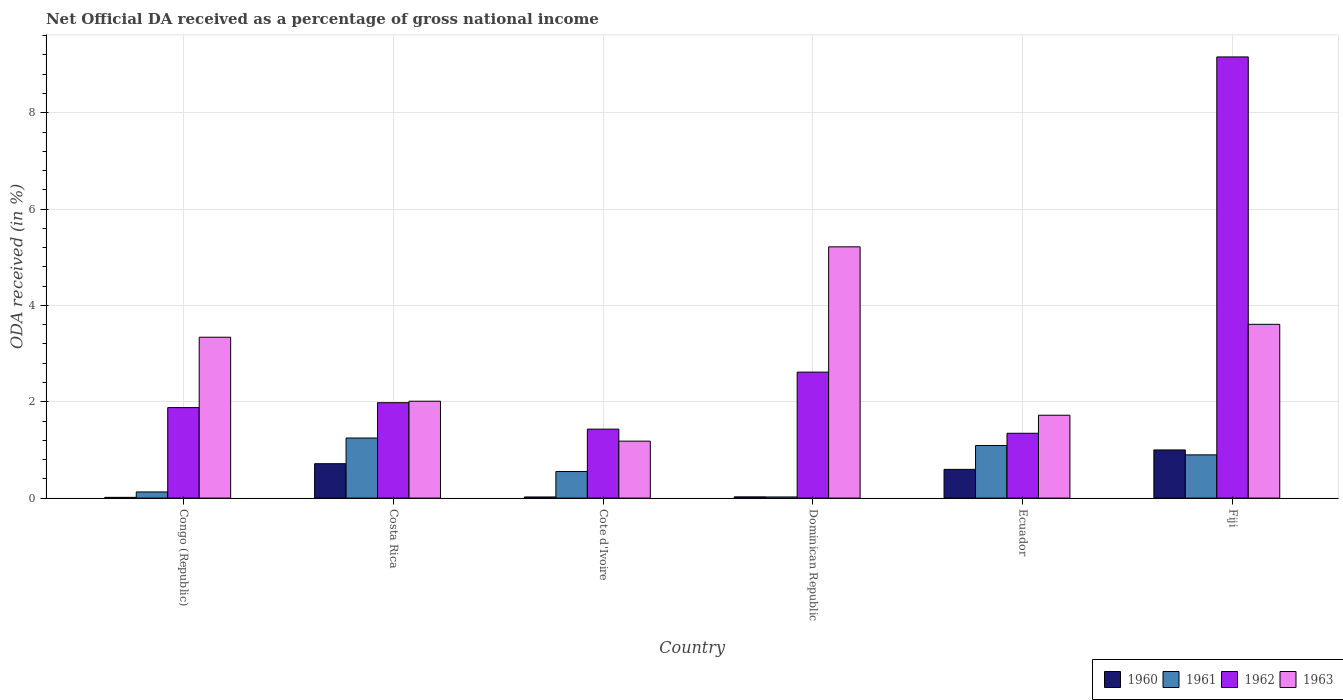How many different coloured bars are there?
Your answer should be compact. 4. Are the number of bars per tick equal to the number of legend labels?
Your answer should be compact. Yes. Are the number of bars on each tick of the X-axis equal?
Keep it short and to the point. Yes. What is the label of the 1st group of bars from the left?
Your answer should be very brief. Congo (Republic). What is the net official DA received in 1960 in Ecuador?
Provide a short and direct response. 0.6. Across all countries, what is the maximum net official DA received in 1962?
Ensure brevity in your answer.  9.16. Across all countries, what is the minimum net official DA received in 1962?
Make the answer very short. 1.35. In which country was the net official DA received in 1960 minimum?
Your answer should be very brief. Congo (Republic). What is the total net official DA received in 1960 in the graph?
Make the answer very short. 2.37. What is the difference between the net official DA received in 1961 in Congo (Republic) and that in Fiji?
Offer a very short reply. -0.77. What is the difference between the net official DA received in 1961 in Cote d'Ivoire and the net official DA received in 1960 in Congo (Republic)?
Your answer should be very brief. 0.54. What is the average net official DA received in 1960 per country?
Make the answer very short. 0.4. What is the difference between the net official DA received of/in 1962 and net official DA received of/in 1963 in Ecuador?
Ensure brevity in your answer.  -0.37. What is the ratio of the net official DA received in 1962 in Dominican Republic to that in Ecuador?
Provide a succinct answer. 1.94. Is the net official DA received in 1962 in Cote d'Ivoire less than that in Dominican Republic?
Offer a very short reply. Yes. Is the difference between the net official DA received in 1962 in Cote d'Ivoire and Dominican Republic greater than the difference between the net official DA received in 1963 in Cote d'Ivoire and Dominican Republic?
Provide a succinct answer. Yes. What is the difference between the highest and the second highest net official DA received in 1960?
Ensure brevity in your answer.  0.29. What is the difference between the highest and the lowest net official DA received in 1961?
Your answer should be very brief. 1.22. Is it the case that in every country, the sum of the net official DA received in 1963 and net official DA received in 1962 is greater than the sum of net official DA received in 1960 and net official DA received in 1961?
Keep it short and to the point. No. Is it the case that in every country, the sum of the net official DA received in 1962 and net official DA received in 1961 is greater than the net official DA received in 1963?
Make the answer very short. No. What is the difference between two consecutive major ticks on the Y-axis?
Offer a very short reply. 2. Does the graph contain grids?
Your answer should be compact. Yes. How many legend labels are there?
Make the answer very short. 4. What is the title of the graph?
Your answer should be very brief. Net Official DA received as a percentage of gross national income. What is the label or title of the Y-axis?
Provide a succinct answer. ODA received (in %). What is the ODA received (in %) in 1960 in Congo (Republic)?
Your response must be concise. 0.02. What is the ODA received (in %) of 1961 in Congo (Republic)?
Keep it short and to the point. 0.13. What is the ODA received (in %) of 1962 in Congo (Republic)?
Make the answer very short. 1.88. What is the ODA received (in %) of 1963 in Congo (Republic)?
Provide a succinct answer. 3.34. What is the ODA received (in %) of 1960 in Costa Rica?
Make the answer very short. 0.71. What is the ODA received (in %) in 1961 in Costa Rica?
Offer a terse response. 1.25. What is the ODA received (in %) in 1962 in Costa Rica?
Give a very brief answer. 1.98. What is the ODA received (in %) of 1963 in Costa Rica?
Your response must be concise. 2.01. What is the ODA received (in %) of 1960 in Cote d'Ivoire?
Your answer should be very brief. 0.02. What is the ODA received (in %) in 1961 in Cote d'Ivoire?
Make the answer very short. 0.55. What is the ODA received (in %) of 1962 in Cote d'Ivoire?
Offer a very short reply. 1.43. What is the ODA received (in %) of 1963 in Cote d'Ivoire?
Your answer should be very brief. 1.18. What is the ODA received (in %) in 1960 in Dominican Republic?
Offer a very short reply. 0.03. What is the ODA received (in %) in 1961 in Dominican Republic?
Ensure brevity in your answer.  0.02. What is the ODA received (in %) in 1962 in Dominican Republic?
Offer a very short reply. 2.62. What is the ODA received (in %) of 1963 in Dominican Republic?
Your answer should be compact. 5.22. What is the ODA received (in %) in 1960 in Ecuador?
Give a very brief answer. 0.6. What is the ODA received (in %) of 1961 in Ecuador?
Your answer should be compact. 1.09. What is the ODA received (in %) in 1962 in Ecuador?
Your answer should be compact. 1.35. What is the ODA received (in %) in 1963 in Ecuador?
Offer a very short reply. 1.72. What is the ODA received (in %) in 1960 in Fiji?
Offer a terse response. 1. What is the ODA received (in %) in 1961 in Fiji?
Your answer should be compact. 0.9. What is the ODA received (in %) in 1962 in Fiji?
Ensure brevity in your answer.  9.16. What is the ODA received (in %) of 1963 in Fiji?
Your response must be concise. 3.61. Across all countries, what is the maximum ODA received (in %) in 1960?
Keep it short and to the point. 1. Across all countries, what is the maximum ODA received (in %) of 1961?
Ensure brevity in your answer.  1.25. Across all countries, what is the maximum ODA received (in %) in 1962?
Your answer should be very brief. 9.16. Across all countries, what is the maximum ODA received (in %) of 1963?
Give a very brief answer. 5.22. Across all countries, what is the minimum ODA received (in %) in 1960?
Offer a terse response. 0.02. Across all countries, what is the minimum ODA received (in %) in 1961?
Your answer should be compact. 0.02. Across all countries, what is the minimum ODA received (in %) of 1962?
Your answer should be compact. 1.35. Across all countries, what is the minimum ODA received (in %) of 1963?
Your response must be concise. 1.18. What is the total ODA received (in %) in 1960 in the graph?
Provide a succinct answer. 2.37. What is the total ODA received (in %) of 1961 in the graph?
Give a very brief answer. 3.94. What is the total ODA received (in %) of 1962 in the graph?
Make the answer very short. 18.41. What is the total ODA received (in %) of 1963 in the graph?
Keep it short and to the point. 17.08. What is the difference between the ODA received (in %) of 1960 in Congo (Republic) and that in Costa Rica?
Your answer should be very brief. -0.7. What is the difference between the ODA received (in %) of 1961 in Congo (Republic) and that in Costa Rica?
Give a very brief answer. -1.12. What is the difference between the ODA received (in %) of 1962 in Congo (Republic) and that in Costa Rica?
Provide a succinct answer. -0.1. What is the difference between the ODA received (in %) in 1963 in Congo (Republic) and that in Costa Rica?
Your response must be concise. 1.33. What is the difference between the ODA received (in %) in 1960 in Congo (Republic) and that in Cote d'Ivoire?
Make the answer very short. -0.01. What is the difference between the ODA received (in %) of 1961 in Congo (Republic) and that in Cote d'Ivoire?
Your response must be concise. -0.42. What is the difference between the ODA received (in %) in 1962 in Congo (Republic) and that in Cote d'Ivoire?
Your answer should be very brief. 0.45. What is the difference between the ODA received (in %) of 1963 in Congo (Republic) and that in Cote d'Ivoire?
Provide a succinct answer. 2.16. What is the difference between the ODA received (in %) of 1960 in Congo (Republic) and that in Dominican Republic?
Your answer should be very brief. -0.01. What is the difference between the ODA received (in %) in 1961 in Congo (Republic) and that in Dominican Republic?
Ensure brevity in your answer.  0.1. What is the difference between the ODA received (in %) of 1962 in Congo (Republic) and that in Dominican Republic?
Offer a very short reply. -0.74. What is the difference between the ODA received (in %) in 1963 in Congo (Republic) and that in Dominican Republic?
Keep it short and to the point. -1.88. What is the difference between the ODA received (in %) of 1960 in Congo (Republic) and that in Ecuador?
Offer a terse response. -0.58. What is the difference between the ODA received (in %) of 1961 in Congo (Republic) and that in Ecuador?
Offer a very short reply. -0.96. What is the difference between the ODA received (in %) in 1962 in Congo (Republic) and that in Ecuador?
Keep it short and to the point. 0.53. What is the difference between the ODA received (in %) in 1963 in Congo (Republic) and that in Ecuador?
Your answer should be compact. 1.62. What is the difference between the ODA received (in %) of 1960 in Congo (Republic) and that in Fiji?
Your answer should be compact. -0.98. What is the difference between the ODA received (in %) in 1961 in Congo (Republic) and that in Fiji?
Offer a very short reply. -0.77. What is the difference between the ODA received (in %) in 1962 in Congo (Republic) and that in Fiji?
Keep it short and to the point. -7.28. What is the difference between the ODA received (in %) of 1963 in Congo (Republic) and that in Fiji?
Keep it short and to the point. -0.27. What is the difference between the ODA received (in %) in 1960 in Costa Rica and that in Cote d'Ivoire?
Offer a terse response. 0.69. What is the difference between the ODA received (in %) in 1961 in Costa Rica and that in Cote d'Ivoire?
Keep it short and to the point. 0.7. What is the difference between the ODA received (in %) of 1962 in Costa Rica and that in Cote d'Ivoire?
Give a very brief answer. 0.55. What is the difference between the ODA received (in %) of 1963 in Costa Rica and that in Cote d'Ivoire?
Make the answer very short. 0.83. What is the difference between the ODA received (in %) in 1960 in Costa Rica and that in Dominican Republic?
Ensure brevity in your answer.  0.69. What is the difference between the ODA received (in %) in 1961 in Costa Rica and that in Dominican Republic?
Offer a very short reply. 1.22. What is the difference between the ODA received (in %) in 1962 in Costa Rica and that in Dominican Republic?
Give a very brief answer. -0.64. What is the difference between the ODA received (in %) of 1963 in Costa Rica and that in Dominican Republic?
Keep it short and to the point. -3.21. What is the difference between the ODA received (in %) in 1960 in Costa Rica and that in Ecuador?
Make the answer very short. 0.12. What is the difference between the ODA received (in %) in 1961 in Costa Rica and that in Ecuador?
Keep it short and to the point. 0.16. What is the difference between the ODA received (in %) in 1962 in Costa Rica and that in Ecuador?
Provide a succinct answer. 0.63. What is the difference between the ODA received (in %) of 1963 in Costa Rica and that in Ecuador?
Keep it short and to the point. 0.29. What is the difference between the ODA received (in %) in 1960 in Costa Rica and that in Fiji?
Make the answer very short. -0.29. What is the difference between the ODA received (in %) of 1961 in Costa Rica and that in Fiji?
Make the answer very short. 0.35. What is the difference between the ODA received (in %) of 1962 in Costa Rica and that in Fiji?
Provide a short and direct response. -7.18. What is the difference between the ODA received (in %) in 1963 in Costa Rica and that in Fiji?
Your answer should be very brief. -1.6. What is the difference between the ODA received (in %) in 1960 in Cote d'Ivoire and that in Dominican Republic?
Ensure brevity in your answer.  -0. What is the difference between the ODA received (in %) in 1961 in Cote d'Ivoire and that in Dominican Republic?
Provide a short and direct response. 0.53. What is the difference between the ODA received (in %) of 1962 in Cote d'Ivoire and that in Dominican Republic?
Offer a terse response. -1.18. What is the difference between the ODA received (in %) in 1963 in Cote d'Ivoire and that in Dominican Republic?
Provide a succinct answer. -4.03. What is the difference between the ODA received (in %) of 1960 in Cote d'Ivoire and that in Ecuador?
Provide a succinct answer. -0.57. What is the difference between the ODA received (in %) in 1961 in Cote d'Ivoire and that in Ecuador?
Your answer should be very brief. -0.54. What is the difference between the ODA received (in %) of 1962 in Cote d'Ivoire and that in Ecuador?
Offer a terse response. 0.09. What is the difference between the ODA received (in %) of 1963 in Cote d'Ivoire and that in Ecuador?
Keep it short and to the point. -0.54. What is the difference between the ODA received (in %) of 1960 in Cote d'Ivoire and that in Fiji?
Offer a very short reply. -0.98. What is the difference between the ODA received (in %) in 1961 in Cote d'Ivoire and that in Fiji?
Give a very brief answer. -0.35. What is the difference between the ODA received (in %) of 1962 in Cote d'Ivoire and that in Fiji?
Provide a short and direct response. -7.73. What is the difference between the ODA received (in %) of 1963 in Cote d'Ivoire and that in Fiji?
Provide a succinct answer. -2.43. What is the difference between the ODA received (in %) of 1960 in Dominican Republic and that in Ecuador?
Offer a very short reply. -0.57. What is the difference between the ODA received (in %) in 1961 in Dominican Republic and that in Ecuador?
Ensure brevity in your answer.  -1.07. What is the difference between the ODA received (in %) in 1962 in Dominican Republic and that in Ecuador?
Offer a terse response. 1.27. What is the difference between the ODA received (in %) in 1963 in Dominican Republic and that in Ecuador?
Your response must be concise. 3.5. What is the difference between the ODA received (in %) in 1960 in Dominican Republic and that in Fiji?
Keep it short and to the point. -0.97. What is the difference between the ODA received (in %) of 1961 in Dominican Republic and that in Fiji?
Make the answer very short. -0.87. What is the difference between the ODA received (in %) of 1962 in Dominican Republic and that in Fiji?
Your answer should be very brief. -6.54. What is the difference between the ODA received (in %) of 1963 in Dominican Republic and that in Fiji?
Offer a very short reply. 1.61. What is the difference between the ODA received (in %) of 1960 in Ecuador and that in Fiji?
Offer a very short reply. -0.4. What is the difference between the ODA received (in %) in 1961 in Ecuador and that in Fiji?
Your answer should be very brief. 0.2. What is the difference between the ODA received (in %) in 1962 in Ecuador and that in Fiji?
Offer a very short reply. -7.81. What is the difference between the ODA received (in %) of 1963 in Ecuador and that in Fiji?
Provide a short and direct response. -1.89. What is the difference between the ODA received (in %) in 1960 in Congo (Republic) and the ODA received (in %) in 1961 in Costa Rica?
Ensure brevity in your answer.  -1.23. What is the difference between the ODA received (in %) in 1960 in Congo (Republic) and the ODA received (in %) in 1962 in Costa Rica?
Your response must be concise. -1.96. What is the difference between the ODA received (in %) of 1960 in Congo (Republic) and the ODA received (in %) of 1963 in Costa Rica?
Offer a very short reply. -2. What is the difference between the ODA received (in %) in 1961 in Congo (Republic) and the ODA received (in %) in 1962 in Costa Rica?
Your response must be concise. -1.85. What is the difference between the ODA received (in %) of 1961 in Congo (Republic) and the ODA received (in %) of 1963 in Costa Rica?
Provide a short and direct response. -1.88. What is the difference between the ODA received (in %) of 1962 in Congo (Republic) and the ODA received (in %) of 1963 in Costa Rica?
Your response must be concise. -0.13. What is the difference between the ODA received (in %) of 1960 in Congo (Republic) and the ODA received (in %) of 1961 in Cote d'Ivoire?
Your answer should be compact. -0.54. What is the difference between the ODA received (in %) in 1960 in Congo (Republic) and the ODA received (in %) in 1962 in Cote d'Ivoire?
Make the answer very short. -1.42. What is the difference between the ODA received (in %) in 1960 in Congo (Republic) and the ODA received (in %) in 1963 in Cote d'Ivoire?
Ensure brevity in your answer.  -1.17. What is the difference between the ODA received (in %) in 1961 in Congo (Republic) and the ODA received (in %) in 1962 in Cote d'Ivoire?
Provide a short and direct response. -1.3. What is the difference between the ODA received (in %) of 1961 in Congo (Republic) and the ODA received (in %) of 1963 in Cote d'Ivoire?
Your answer should be very brief. -1.05. What is the difference between the ODA received (in %) in 1962 in Congo (Republic) and the ODA received (in %) in 1963 in Cote d'Ivoire?
Your answer should be very brief. 0.7. What is the difference between the ODA received (in %) in 1960 in Congo (Republic) and the ODA received (in %) in 1961 in Dominican Republic?
Your answer should be compact. -0.01. What is the difference between the ODA received (in %) in 1960 in Congo (Republic) and the ODA received (in %) in 1962 in Dominican Republic?
Your answer should be very brief. -2.6. What is the difference between the ODA received (in %) in 1960 in Congo (Republic) and the ODA received (in %) in 1963 in Dominican Republic?
Make the answer very short. -5.2. What is the difference between the ODA received (in %) of 1961 in Congo (Republic) and the ODA received (in %) of 1962 in Dominican Republic?
Provide a short and direct response. -2.49. What is the difference between the ODA received (in %) in 1961 in Congo (Republic) and the ODA received (in %) in 1963 in Dominican Republic?
Ensure brevity in your answer.  -5.09. What is the difference between the ODA received (in %) of 1962 in Congo (Republic) and the ODA received (in %) of 1963 in Dominican Republic?
Your answer should be compact. -3.34. What is the difference between the ODA received (in %) of 1960 in Congo (Republic) and the ODA received (in %) of 1961 in Ecuador?
Offer a very short reply. -1.08. What is the difference between the ODA received (in %) in 1960 in Congo (Republic) and the ODA received (in %) in 1962 in Ecuador?
Provide a succinct answer. -1.33. What is the difference between the ODA received (in %) of 1960 in Congo (Republic) and the ODA received (in %) of 1963 in Ecuador?
Your response must be concise. -1.71. What is the difference between the ODA received (in %) in 1961 in Congo (Republic) and the ODA received (in %) in 1962 in Ecuador?
Provide a succinct answer. -1.22. What is the difference between the ODA received (in %) of 1961 in Congo (Republic) and the ODA received (in %) of 1963 in Ecuador?
Your answer should be very brief. -1.59. What is the difference between the ODA received (in %) in 1962 in Congo (Republic) and the ODA received (in %) in 1963 in Ecuador?
Ensure brevity in your answer.  0.16. What is the difference between the ODA received (in %) in 1960 in Congo (Republic) and the ODA received (in %) in 1961 in Fiji?
Ensure brevity in your answer.  -0.88. What is the difference between the ODA received (in %) of 1960 in Congo (Republic) and the ODA received (in %) of 1962 in Fiji?
Keep it short and to the point. -9.14. What is the difference between the ODA received (in %) of 1960 in Congo (Republic) and the ODA received (in %) of 1963 in Fiji?
Offer a very short reply. -3.59. What is the difference between the ODA received (in %) of 1961 in Congo (Republic) and the ODA received (in %) of 1962 in Fiji?
Offer a very short reply. -9.03. What is the difference between the ODA received (in %) of 1961 in Congo (Republic) and the ODA received (in %) of 1963 in Fiji?
Keep it short and to the point. -3.48. What is the difference between the ODA received (in %) of 1962 in Congo (Republic) and the ODA received (in %) of 1963 in Fiji?
Provide a succinct answer. -1.73. What is the difference between the ODA received (in %) in 1960 in Costa Rica and the ODA received (in %) in 1961 in Cote d'Ivoire?
Make the answer very short. 0.16. What is the difference between the ODA received (in %) of 1960 in Costa Rica and the ODA received (in %) of 1962 in Cote d'Ivoire?
Give a very brief answer. -0.72. What is the difference between the ODA received (in %) of 1960 in Costa Rica and the ODA received (in %) of 1963 in Cote d'Ivoire?
Ensure brevity in your answer.  -0.47. What is the difference between the ODA received (in %) in 1961 in Costa Rica and the ODA received (in %) in 1962 in Cote d'Ivoire?
Offer a terse response. -0.18. What is the difference between the ODA received (in %) of 1961 in Costa Rica and the ODA received (in %) of 1963 in Cote d'Ivoire?
Give a very brief answer. 0.07. What is the difference between the ODA received (in %) of 1962 in Costa Rica and the ODA received (in %) of 1963 in Cote d'Ivoire?
Your answer should be compact. 0.8. What is the difference between the ODA received (in %) in 1960 in Costa Rica and the ODA received (in %) in 1961 in Dominican Republic?
Your answer should be very brief. 0.69. What is the difference between the ODA received (in %) in 1960 in Costa Rica and the ODA received (in %) in 1962 in Dominican Republic?
Provide a succinct answer. -1.9. What is the difference between the ODA received (in %) of 1960 in Costa Rica and the ODA received (in %) of 1963 in Dominican Republic?
Your answer should be very brief. -4.5. What is the difference between the ODA received (in %) of 1961 in Costa Rica and the ODA received (in %) of 1962 in Dominican Republic?
Your answer should be compact. -1.37. What is the difference between the ODA received (in %) of 1961 in Costa Rica and the ODA received (in %) of 1963 in Dominican Republic?
Your answer should be compact. -3.97. What is the difference between the ODA received (in %) of 1962 in Costa Rica and the ODA received (in %) of 1963 in Dominican Republic?
Provide a succinct answer. -3.24. What is the difference between the ODA received (in %) of 1960 in Costa Rica and the ODA received (in %) of 1961 in Ecuador?
Offer a terse response. -0.38. What is the difference between the ODA received (in %) in 1960 in Costa Rica and the ODA received (in %) in 1962 in Ecuador?
Give a very brief answer. -0.63. What is the difference between the ODA received (in %) of 1960 in Costa Rica and the ODA received (in %) of 1963 in Ecuador?
Your answer should be very brief. -1.01. What is the difference between the ODA received (in %) in 1961 in Costa Rica and the ODA received (in %) in 1962 in Ecuador?
Make the answer very short. -0.1. What is the difference between the ODA received (in %) of 1961 in Costa Rica and the ODA received (in %) of 1963 in Ecuador?
Make the answer very short. -0.47. What is the difference between the ODA received (in %) of 1962 in Costa Rica and the ODA received (in %) of 1963 in Ecuador?
Your response must be concise. 0.26. What is the difference between the ODA received (in %) in 1960 in Costa Rica and the ODA received (in %) in 1961 in Fiji?
Keep it short and to the point. -0.18. What is the difference between the ODA received (in %) of 1960 in Costa Rica and the ODA received (in %) of 1962 in Fiji?
Provide a succinct answer. -8.45. What is the difference between the ODA received (in %) in 1960 in Costa Rica and the ODA received (in %) in 1963 in Fiji?
Your answer should be very brief. -2.89. What is the difference between the ODA received (in %) of 1961 in Costa Rica and the ODA received (in %) of 1962 in Fiji?
Offer a very short reply. -7.91. What is the difference between the ODA received (in %) in 1961 in Costa Rica and the ODA received (in %) in 1963 in Fiji?
Keep it short and to the point. -2.36. What is the difference between the ODA received (in %) in 1962 in Costa Rica and the ODA received (in %) in 1963 in Fiji?
Your answer should be very brief. -1.63. What is the difference between the ODA received (in %) in 1960 in Cote d'Ivoire and the ODA received (in %) in 1961 in Dominican Republic?
Your response must be concise. -0. What is the difference between the ODA received (in %) in 1960 in Cote d'Ivoire and the ODA received (in %) in 1962 in Dominican Republic?
Your response must be concise. -2.59. What is the difference between the ODA received (in %) in 1960 in Cote d'Ivoire and the ODA received (in %) in 1963 in Dominican Republic?
Your answer should be compact. -5.19. What is the difference between the ODA received (in %) of 1961 in Cote d'Ivoire and the ODA received (in %) of 1962 in Dominican Republic?
Keep it short and to the point. -2.06. What is the difference between the ODA received (in %) in 1961 in Cote d'Ivoire and the ODA received (in %) in 1963 in Dominican Republic?
Provide a short and direct response. -4.67. What is the difference between the ODA received (in %) of 1962 in Cote d'Ivoire and the ODA received (in %) of 1963 in Dominican Republic?
Keep it short and to the point. -3.79. What is the difference between the ODA received (in %) of 1960 in Cote d'Ivoire and the ODA received (in %) of 1961 in Ecuador?
Provide a short and direct response. -1.07. What is the difference between the ODA received (in %) of 1960 in Cote d'Ivoire and the ODA received (in %) of 1962 in Ecuador?
Provide a succinct answer. -1.32. What is the difference between the ODA received (in %) in 1960 in Cote d'Ivoire and the ODA received (in %) in 1963 in Ecuador?
Your answer should be compact. -1.7. What is the difference between the ODA received (in %) of 1961 in Cote d'Ivoire and the ODA received (in %) of 1962 in Ecuador?
Your response must be concise. -0.79. What is the difference between the ODA received (in %) in 1961 in Cote d'Ivoire and the ODA received (in %) in 1963 in Ecuador?
Ensure brevity in your answer.  -1.17. What is the difference between the ODA received (in %) in 1962 in Cote d'Ivoire and the ODA received (in %) in 1963 in Ecuador?
Your response must be concise. -0.29. What is the difference between the ODA received (in %) of 1960 in Cote d'Ivoire and the ODA received (in %) of 1961 in Fiji?
Your answer should be compact. -0.87. What is the difference between the ODA received (in %) of 1960 in Cote d'Ivoire and the ODA received (in %) of 1962 in Fiji?
Your answer should be very brief. -9.14. What is the difference between the ODA received (in %) in 1960 in Cote d'Ivoire and the ODA received (in %) in 1963 in Fiji?
Your answer should be compact. -3.58. What is the difference between the ODA received (in %) in 1961 in Cote d'Ivoire and the ODA received (in %) in 1962 in Fiji?
Offer a terse response. -8.61. What is the difference between the ODA received (in %) in 1961 in Cote d'Ivoire and the ODA received (in %) in 1963 in Fiji?
Give a very brief answer. -3.06. What is the difference between the ODA received (in %) in 1962 in Cote d'Ivoire and the ODA received (in %) in 1963 in Fiji?
Provide a succinct answer. -2.18. What is the difference between the ODA received (in %) of 1960 in Dominican Republic and the ODA received (in %) of 1961 in Ecuador?
Ensure brevity in your answer.  -1.07. What is the difference between the ODA received (in %) of 1960 in Dominican Republic and the ODA received (in %) of 1962 in Ecuador?
Ensure brevity in your answer.  -1.32. What is the difference between the ODA received (in %) of 1960 in Dominican Republic and the ODA received (in %) of 1963 in Ecuador?
Offer a very short reply. -1.69. What is the difference between the ODA received (in %) of 1961 in Dominican Republic and the ODA received (in %) of 1962 in Ecuador?
Provide a short and direct response. -1.32. What is the difference between the ODA received (in %) in 1961 in Dominican Republic and the ODA received (in %) in 1963 in Ecuador?
Your answer should be compact. -1.7. What is the difference between the ODA received (in %) in 1962 in Dominican Republic and the ODA received (in %) in 1963 in Ecuador?
Provide a succinct answer. 0.9. What is the difference between the ODA received (in %) of 1960 in Dominican Republic and the ODA received (in %) of 1961 in Fiji?
Make the answer very short. -0.87. What is the difference between the ODA received (in %) of 1960 in Dominican Republic and the ODA received (in %) of 1962 in Fiji?
Make the answer very short. -9.13. What is the difference between the ODA received (in %) in 1960 in Dominican Republic and the ODA received (in %) in 1963 in Fiji?
Your answer should be compact. -3.58. What is the difference between the ODA received (in %) in 1961 in Dominican Republic and the ODA received (in %) in 1962 in Fiji?
Give a very brief answer. -9.14. What is the difference between the ODA received (in %) in 1961 in Dominican Republic and the ODA received (in %) in 1963 in Fiji?
Offer a terse response. -3.58. What is the difference between the ODA received (in %) of 1962 in Dominican Republic and the ODA received (in %) of 1963 in Fiji?
Your answer should be very brief. -0.99. What is the difference between the ODA received (in %) in 1960 in Ecuador and the ODA received (in %) in 1961 in Fiji?
Your response must be concise. -0.3. What is the difference between the ODA received (in %) in 1960 in Ecuador and the ODA received (in %) in 1962 in Fiji?
Your response must be concise. -8.56. What is the difference between the ODA received (in %) in 1960 in Ecuador and the ODA received (in %) in 1963 in Fiji?
Ensure brevity in your answer.  -3.01. What is the difference between the ODA received (in %) of 1961 in Ecuador and the ODA received (in %) of 1962 in Fiji?
Your answer should be compact. -8.07. What is the difference between the ODA received (in %) in 1961 in Ecuador and the ODA received (in %) in 1963 in Fiji?
Your answer should be very brief. -2.52. What is the difference between the ODA received (in %) in 1962 in Ecuador and the ODA received (in %) in 1963 in Fiji?
Ensure brevity in your answer.  -2.26. What is the average ODA received (in %) in 1960 per country?
Your answer should be very brief. 0.4. What is the average ODA received (in %) in 1961 per country?
Offer a terse response. 0.66. What is the average ODA received (in %) in 1962 per country?
Make the answer very short. 3.07. What is the average ODA received (in %) of 1963 per country?
Your response must be concise. 2.85. What is the difference between the ODA received (in %) in 1960 and ODA received (in %) in 1961 in Congo (Republic)?
Your response must be concise. -0.11. What is the difference between the ODA received (in %) in 1960 and ODA received (in %) in 1962 in Congo (Republic)?
Your answer should be very brief. -1.86. What is the difference between the ODA received (in %) of 1960 and ODA received (in %) of 1963 in Congo (Republic)?
Provide a succinct answer. -3.32. What is the difference between the ODA received (in %) in 1961 and ODA received (in %) in 1962 in Congo (Republic)?
Keep it short and to the point. -1.75. What is the difference between the ODA received (in %) in 1961 and ODA received (in %) in 1963 in Congo (Republic)?
Make the answer very short. -3.21. What is the difference between the ODA received (in %) in 1962 and ODA received (in %) in 1963 in Congo (Republic)?
Provide a succinct answer. -1.46. What is the difference between the ODA received (in %) of 1960 and ODA received (in %) of 1961 in Costa Rica?
Your response must be concise. -0.53. What is the difference between the ODA received (in %) in 1960 and ODA received (in %) in 1962 in Costa Rica?
Give a very brief answer. -1.27. What is the difference between the ODA received (in %) of 1960 and ODA received (in %) of 1963 in Costa Rica?
Offer a terse response. -1.3. What is the difference between the ODA received (in %) in 1961 and ODA received (in %) in 1962 in Costa Rica?
Your response must be concise. -0.73. What is the difference between the ODA received (in %) of 1961 and ODA received (in %) of 1963 in Costa Rica?
Your response must be concise. -0.76. What is the difference between the ODA received (in %) of 1962 and ODA received (in %) of 1963 in Costa Rica?
Your answer should be compact. -0.03. What is the difference between the ODA received (in %) of 1960 and ODA received (in %) of 1961 in Cote d'Ivoire?
Your answer should be compact. -0.53. What is the difference between the ODA received (in %) in 1960 and ODA received (in %) in 1962 in Cote d'Ivoire?
Your answer should be very brief. -1.41. What is the difference between the ODA received (in %) in 1960 and ODA received (in %) in 1963 in Cote d'Ivoire?
Provide a short and direct response. -1.16. What is the difference between the ODA received (in %) of 1961 and ODA received (in %) of 1962 in Cote d'Ivoire?
Provide a short and direct response. -0.88. What is the difference between the ODA received (in %) in 1961 and ODA received (in %) in 1963 in Cote d'Ivoire?
Provide a succinct answer. -0.63. What is the difference between the ODA received (in %) in 1962 and ODA received (in %) in 1963 in Cote d'Ivoire?
Your answer should be compact. 0.25. What is the difference between the ODA received (in %) of 1960 and ODA received (in %) of 1961 in Dominican Republic?
Your answer should be very brief. 0. What is the difference between the ODA received (in %) of 1960 and ODA received (in %) of 1962 in Dominican Republic?
Your answer should be compact. -2.59. What is the difference between the ODA received (in %) of 1960 and ODA received (in %) of 1963 in Dominican Republic?
Your answer should be very brief. -5.19. What is the difference between the ODA received (in %) of 1961 and ODA received (in %) of 1962 in Dominican Republic?
Give a very brief answer. -2.59. What is the difference between the ODA received (in %) of 1961 and ODA received (in %) of 1963 in Dominican Republic?
Provide a short and direct response. -5.19. What is the difference between the ODA received (in %) of 1962 and ODA received (in %) of 1963 in Dominican Republic?
Provide a short and direct response. -2.6. What is the difference between the ODA received (in %) in 1960 and ODA received (in %) in 1961 in Ecuador?
Give a very brief answer. -0.5. What is the difference between the ODA received (in %) of 1960 and ODA received (in %) of 1962 in Ecuador?
Your response must be concise. -0.75. What is the difference between the ODA received (in %) of 1960 and ODA received (in %) of 1963 in Ecuador?
Ensure brevity in your answer.  -1.12. What is the difference between the ODA received (in %) in 1961 and ODA received (in %) in 1962 in Ecuador?
Your response must be concise. -0.25. What is the difference between the ODA received (in %) in 1961 and ODA received (in %) in 1963 in Ecuador?
Provide a short and direct response. -0.63. What is the difference between the ODA received (in %) of 1962 and ODA received (in %) of 1963 in Ecuador?
Provide a short and direct response. -0.37. What is the difference between the ODA received (in %) of 1960 and ODA received (in %) of 1961 in Fiji?
Ensure brevity in your answer.  0.1. What is the difference between the ODA received (in %) of 1960 and ODA received (in %) of 1962 in Fiji?
Provide a short and direct response. -8.16. What is the difference between the ODA received (in %) in 1960 and ODA received (in %) in 1963 in Fiji?
Your answer should be compact. -2.61. What is the difference between the ODA received (in %) of 1961 and ODA received (in %) of 1962 in Fiji?
Provide a succinct answer. -8.26. What is the difference between the ODA received (in %) of 1961 and ODA received (in %) of 1963 in Fiji?
Ensure brevity in your answer.  -2.71. What is the difference between the ODA received (in %) of 1962 and ODA received (in %) of 1963 in Fiji?
Make the answer very short. 5.55. What is the ratio of the ODA received (in %) of 1960 in Congo (Republic) to that in Costa Rica?
Ensure brevity in your answer.  0.02. What is the ratio of the ODA received (in %) in 1961 in Congo (Republic) to that in Costa Rica?
Your answer should be compact. 0.1. What is the ratio of the ODA received (in %) in 1962 in Congo (Republic) to that in Costa Rica?
Offer a very short reply. 0.95. What is the ratio of the ODA received (in %) in 1963 in Congo (Republic) to that in Costa Rica?
Provide a short and direct response. 1.66. What is the ratio of the ODA received (in %) in 1960 in Congo (Republic) to that in Cote d'Ivoire?
Make the answer very short. 0.66. What is the ratio of the ODA received (in %) of 1961 in Congo (Republic) to that in Cote d'Ivoire?
Provide a short and direct response. 0.23. What is the ratio of the ODA received (in %) of 1962 in Congo (Republic) to that in Cote d'Ivoire?
Give a very brief answer. 1.31. What is the ratio of the ODA received (in %) of 1963 in Congo (Republic) to that in Cote d'Ivoire?
Offer a very short reply. 2.83. What is the ratio of the ODA received (in %) in 1960 in Congo (Republic) to that in Dominican Republic?
Provide a succinct answer. 0.6. What is the ratio of the ODA received (in %) in 1961 in Congo (Republic) to that in Dominican Republic?
Your response must be concise. 5.41. What is the ratio of the ODA received (in %) in 1962 in Congo (Republic) to that in Dominican Republic?
Make the answer very short. 0.72. What is the ratio of the ODA received (in %) in 1963 in Congo (Republic) to that in Dominican Republic?
Your response must be concise. 0.64. What is the ratio of the ODA received (in %) of 1960 in Congo (Republic) to that in Ecuador?
Your response must be concise. 0.03. What is the ratio of the ODA received (in %) in 1961 in Congo (Republic) to that in Ecuador?
Ensure brevity in your answer.  0.12. What is the ratio of the ODA received (in %) of 1962 in Congo (Republic) to that in Ecuador?
Keep it short and to the point. 1.4. What is the ratio of the ODA received (in %) of 1963 in Congo (Republic) to that in Ecuador?
Provide a succinct answer. 1.94. What is the ratio of the ODA received (in %) of 1960 in Congo (Republic) to that in Fiji?
Your response must be concise. 0.02. What is the ratio of the ODA received (in %) of 1961 in Congo (Republic) to that in Fiji?
Your response must be concise. 0.14. What is the ratio of the ODA received (in %) of 1962 in Congo (Republic) to that in Fiji?
Offer a terse response. 0.21. What is the ratio of the ODA received (in %) of 1963 in Congo (Republic) to that in Fiji?
Your answer should be compact. 0.93. What is the ratio of the ODA received (in %) of 1960 in Costa Rica to that in Cote d'Ivoire?
Give a very brief answer. 30.57. What is the ratio of the ODA received (in %) in 1961 in Costa Rica to that in Cote d'Ivoire?
Provide a succinct answer. 2.26. What is the ratio of the ODA received (in %) in 1962 in Costa Rica to that in Cote d'Ivoire?
Provide a short and direct response. 1.38. What is the ratio of the ODA received (in %) of 1963 in Costa Rica to that in Cote d'Ivoire?
Ensure brevity in your answer.  1.7. What is the ratio of the ODA received (in %) in 1960 in Costa Rica to that in Dominican Republic?
Your answer should be very brief. 27.82. What is the ratio of the ODA received (in %) of 1961 in Costa Rica to that in Dominican Republic?
Keep it short and to the point. 52.85. What is the ratio of the ODA received (in %) in 1962 in Costa Rica to that in Dominican Republic?
Offer a very short reply. 0.76. What is the ratio of the ODA received (in %) in 1963 in Costa Rica to that in Dominican Republic?
Ensure brevity in your answer.  0.39. What is the ratio of the ODA received (in %) in 1960 in Costa Rica to that in Ecuador?
Provide a succinct answer. 1.2. What is the ratio of the ODA received (in %) in 1961 in Costa Rica to that in Ecuador?
Ensure brevity in your answer.  1.14. What is the ratio of the ODA received (in %) in 1962 in Costa Rica to that in Ecuador?
Make the answer very short. 1.47. What is the ratio of the ODA received (in %) of 1963 in Costa Rica to that in Ecuador?
Provide a short and direct response. 1.17. What is the ratio of the ODA received (in %) of 1960 in Costa Rica to that in Fiji?
Offer a terse response. 0.71. What is the ratio of the ODA received (in %) of 1961 in Costa Rica to that in Fiji?
Keep it short and to the point. 1.39. What is the ratio of the ODA received (in %) in 1962 in Costa Rica to that in Fiji?
Offer a terse response. 0.22. What is the ratio of the ODA received (in %) in 1963 in Costa Rica to that in Fiji?
Your answer should be very brief. 0.56. What is the ratio of the ODA received (in %) of 1960 in Cote d'Ivoire to that in Dominican Republic?
Keep it short and to the point. 0.91. What is the ratio of the ODA received (in %) of 1961 in Cote d'Ivoire to that in Dominican Republic?
Offer a very short reply. 23.38. What is the ratio of the ODA received (in %) of 1962 in Cote d'Ivoire to that in Dominican Republic?
Ensure brevity in your answer.  0.55. What is the ratio of the ODA received (in %) in 1963 in Cote d'Ivoire to that in Dominican Republic?
Make the answer very short. 0.23. What is the ratio of the ODA received (in %) of 1960 in Cote d'Ivoire to that in Ecuador?
Provide a short and direct response. 0.04. What is the ratio of the ODA received (in %) in 1961 in Cote d'Ivoire to that in Ecuador?
Provide a short and direct response. 0.51. What is the ratio of the ODA received (in %) of 1962 in Cote d'Ivoire to that in Ecuador?
Make the answer very short. 1.06. What is the ratio of the ODA received (in %) of 1963 in Cote d'Ivoire to that in Ecuador?
Make the answer very short. 0.69. What is the ratio of the ODA received (in %) in 1960 in Cote d'Ivoire to that in Fiji?
Your answer should be compact. 0.02. What is the ratio of the ODA received (in %) of 1961 in Cote d'Ivoire to that in Fiji?
Your response must be concise. 0.61. What is the ratio of the ODA received (in %) in 1962 in Cote d'Ivoire to that in Fiji?
Offer a very short reply. 0.16. What is the ratio of the ODA received (in %) of 1963 in Cote d'Ivoire to that in Fiji?
Keep it short and to the point. 0.33. What is the ratio of the ODA received (in %) of 1960 in Dominican Republic to that in Ecuador?
Your response must be concise. 0.04. What is the ratio of the ODA received (in %) in 1961 in Dominican Republic to that in Ecuador?
Keep it short and to the point. 0.02. What is the ratio of the ODA received (in %) in 1962 in Dominican Republic to that in Ecuador?
Provide a succinct answer. 1.94. What is the ratio of the ODA received (in %) of 1963 in Dominican Republic to that in Ecuador?
Keep it short and to the point. 3.03. What is the ratio of the ODA received (in %) of 1960 in Dominican Republic to that in Fiji?
Provide a short and direct response. 0.03. What is the ratio of the ODA received (in %) of 1961 in Dominican Republic to that in Fiji?
Offer a terse response. 0.03. What is the ratio of the ODA received (in %) in 1962 in Dominican Republic to that in Fiji?
Keep it short and to the point. 0.29. What is the ratio of the ODA received (in %) in 1963 in Dominican Republic to that in Fiji?
Offer a terse response. 1.45. What is the ratio of the ODA received (in %) of 1960 in Ecuador to that in Fiji?
Make the answer very short. 0.6. What is the ratio of the ODA received (in %) of 1961 in Ecuador to that in Fiji?
Offer a very short reply. 1.22. What is the ratio of the ODA received (in %) of 1962 in Ecuador to that in Fiji?
Your answer should be compact. 0.15. What is the ratio of the ODA received (in %) of 1963 in Ecuador to that in Fiji?
Provide a succinct answer. 0.48. What is the difference between the highest and the second highest ODA received (in %) of 1960?
Your answer should be compact. 0.29. What is the difference between the highest and the second highest ODA received (in %) of 1961?
Offer a terse response. 0.16. What is the difference between the highest and the second highest ODA received (in %) of 1962?
Your answer should be very brief. 6.54. What is the difference between the highest and the second highest ODA received (in %) of 1963?
Provide a succinct answer. 1.61. What is the difference between the highest and the lowest ODA received (in %) of 1960?
Give a very brief answer. 0.98. What is the difference between the highest and the lowest ODA received (in %) in 1961?
Provide a short and direct response. 1.22. What is the difference between the highest and the lowest ODA received (in %) in 1962?
Offer a terse response. 7.81. What is the difference between the highest and the lowest ODA received (in %) in 1963?
Your answer should be very brief. 4.03. 